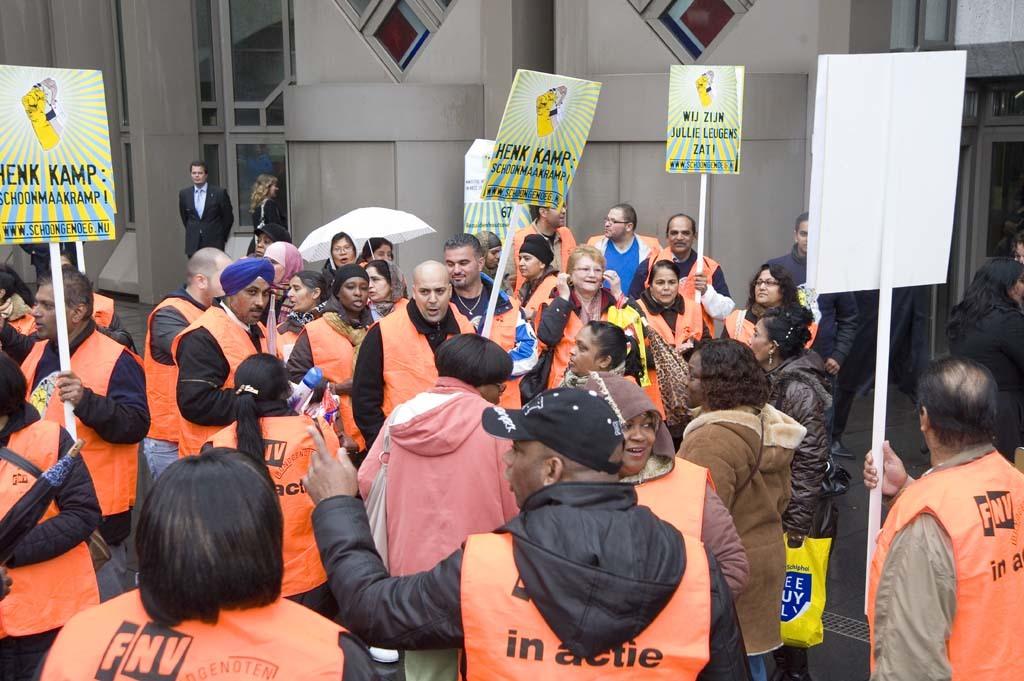What organization are the people in the orange vests probably a part of?
Offer a very short reply. Fnv. What is the website link on the sign?
Provide a short and direct response. Www.schoongenoeg.nu. 